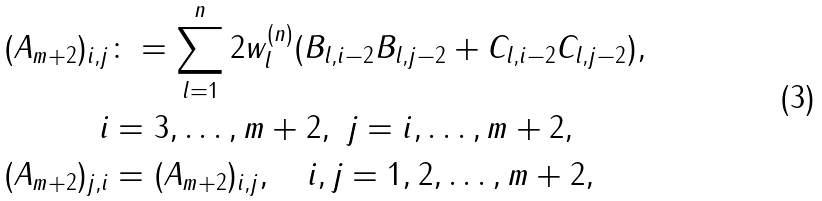<formula> <loc_0><loc_0><loc_500><loc_500>( A _ { m + 2 } ) _ { i , j } & \colon = \sum _ { l = 1 } ^ { n } 2 w _ { l } ^ { ( n ) } ( B _ { l , i - 2 } B _ { l , j - 2 } + C _ { l , i - 2 } C _ { l , j - 2 } ) , \\ i & = 3 , \hdots , m + 2 , \ j = i , \hdots , m + 2 , \\ ( A _ { m + 2 } ) _ { j , i } & = ( A _ { m + 2 } ) _ { i , j } , \quad i , j = 1 , 2 , \hdots , m + 2 ,</formula> 